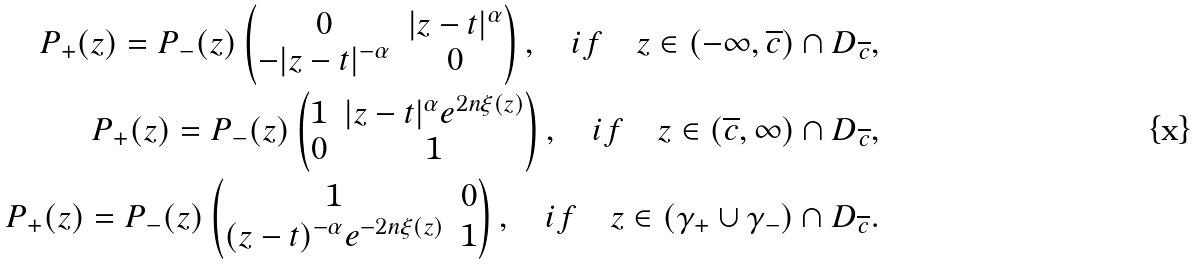Convert formula to latex. <formula><loc_0><loc_0><loc_500><loc_500>P _ { + } ( z ) = P _ { - } ( z ) \begin{pmatrix} 0 & | z - t | ^ { \alpha } \\ - | z - t | ^ { - \alpha } & 0 \end{pmatrix} , \quad i f \quad z \in ( - \infty , \overline { c } ) \cap D _ { \overline { c } } , \\ P _ { + } ( z ) = P _ { - } ( z ) \begin{pmatrix} 1 & | z - t | ^ { \alpha } e ^ { 2 n \xi ( z ) } \\ 0 & 1 \end{pmatrix} , \quad i f \quad z \in ( \overline { c } , \infty ) \cap D _ { \overline { c } } , \\ P _ { + } ( z ) = P _ { - } ( z ) \begin{pmatrix} 1 & 0 \\ ( z - t ) ^ { - \alpha } e ^ { - 2 n \xi ( z ) } & 1 \end{pmatrix} , \quad i f \quad z \in ( \gamma _ { + } \cup \gamma _ { - } ) \cap D _ { \overline { c } } .</formula> 